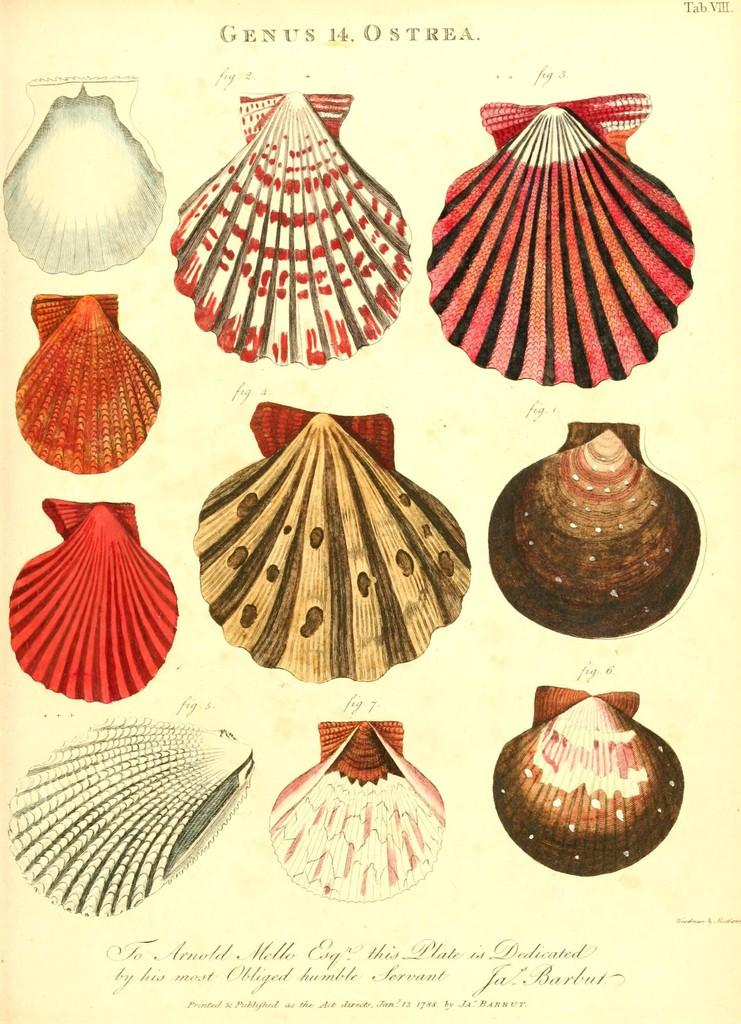What type of objects can be seen in the image? There are shells depicted in the image. Can you describe any text present in the image? Yes, there is writing on the top and bottom of the image. How many friends can be seen playing with the pig in the image? There are no friends or pigs present in the image; it only features shells and writing. 